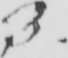What is written in this line of handwriting? 3 . 